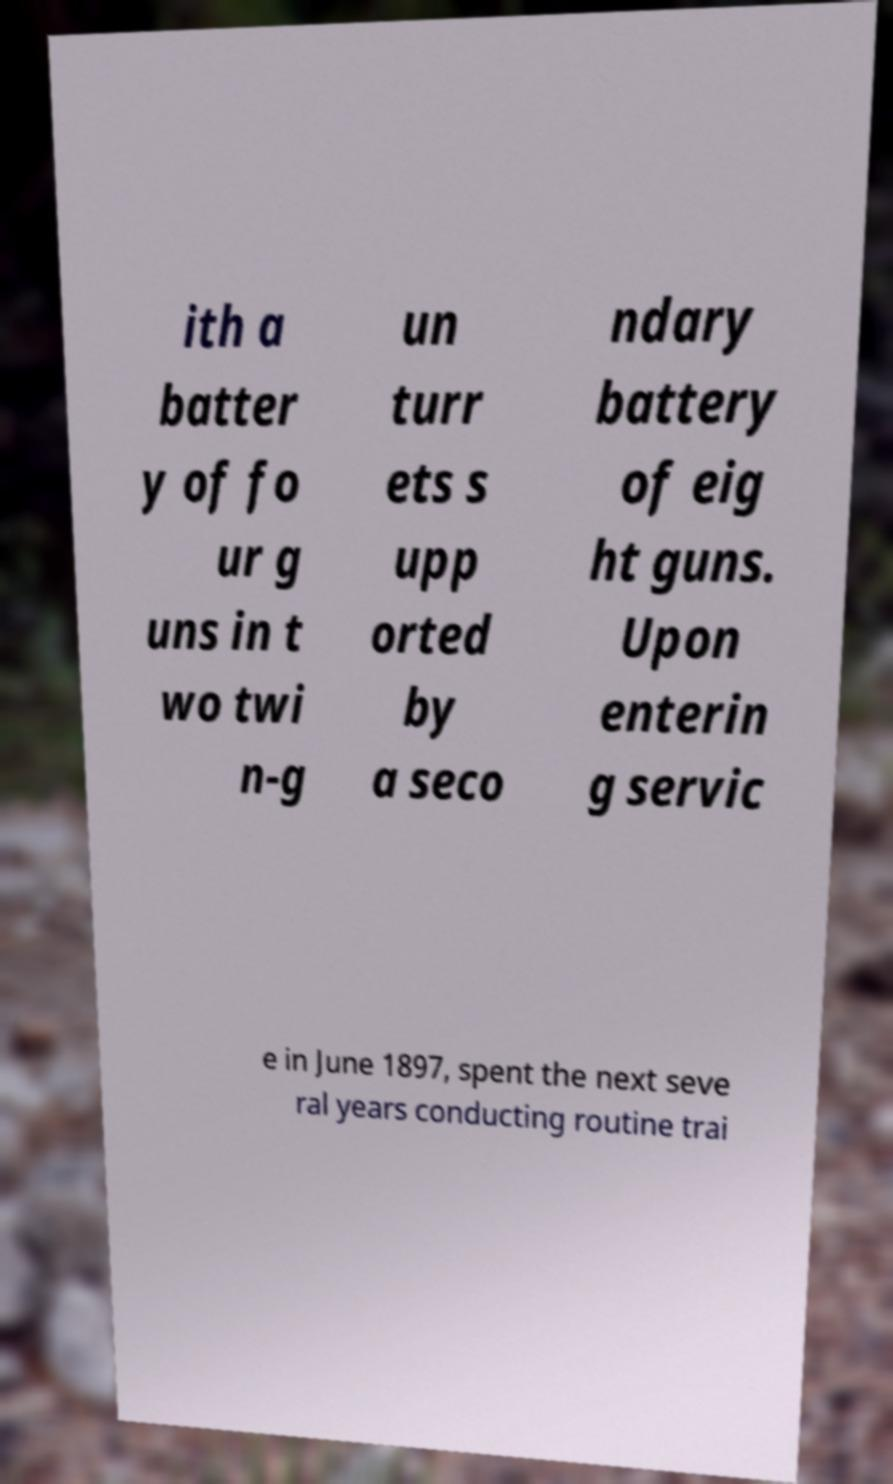I need the written content from this picture converted into text. Can you do that? ith a batter y of fo ur g uns in t wo twi n-g un turr ets s upp orted by a seco ndary battery of eig ht guns. Upon enterin g servic e in June 1897, spent the next seve ral years conducting routine trai 